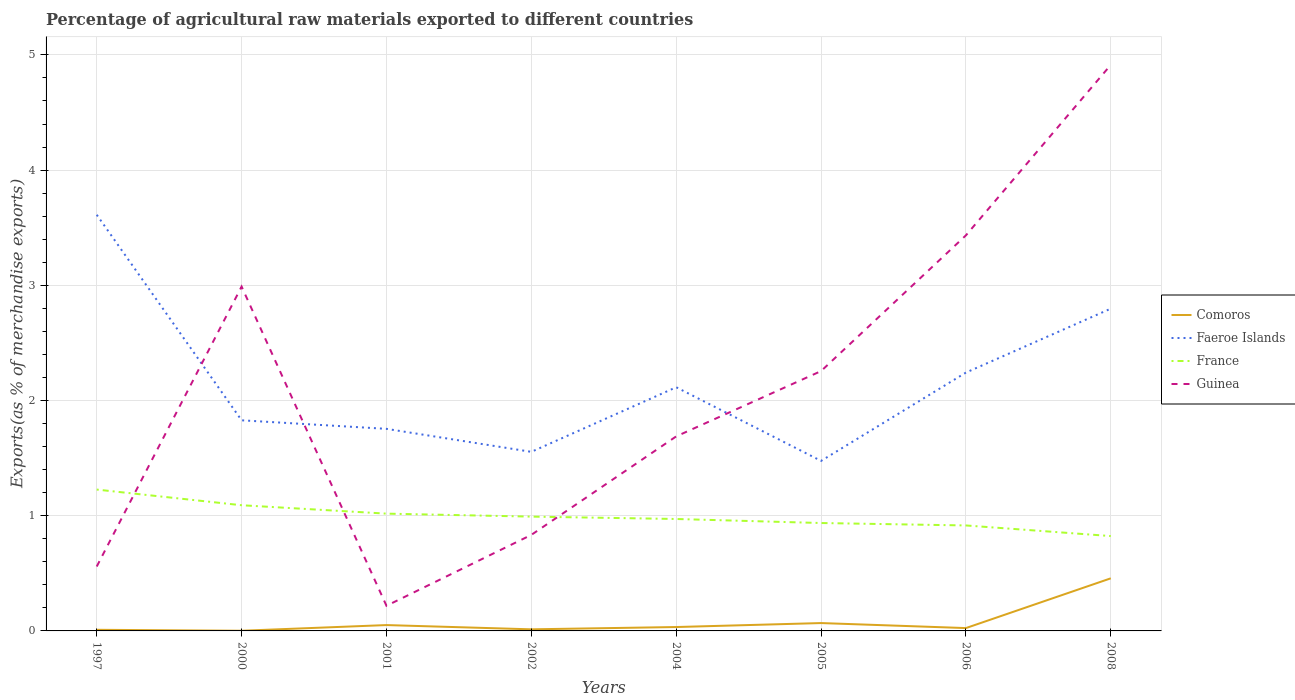Is the number of lines equal to the number of legend labels?
Provide a succinct answer. Yes. Across all years, what is the maximum percentage of exports to different countries in France?
Your response must be concise. 0.82. In which year was the percentage of exports to different countries in Guinea maximum?
Your answer should be very brief. 2001. What is the total percentage of exports to different countries in Faeroe Islands in the graph?
Offer a very short reply. -0.29. What is the difference between the highest and the second highest percentage of exports to different countries in Comoros?
Your response must be concise. 0.46. Is the percentage of exports to different countries in Comoros strictly greater than the percentage of exports to different countries in Faeroe Islands over the years?
Give a very brief answer. Yes. How many lines are there?
Offer a very short reply. 4. Where does the legend appear in the graph?
Your response must be concise. Center right. How are the legend labels stacked?
Provide a short and direct response. Vertical. What is the title of the graph?
Give a very brief answer. Percentage of agricultural raw materials exported to different countries. Does "Antigua and Barbuda" appear as one of the legend labels in the graph?
Make the answer very short. No. What is the label or title of the X-axis?
Offer a very short reply. Years. What is the label or title of the Y-axis?
Provide a short and direct response. Exports(as % of merchandise exports). What is the Exports(as % of merchandise exports) of Comoros in 1997?
Give a very brief answer. 0.01. What is the Exports(as % of merchandise exports) in Faeroe Islands in 1997?
Provide a short and direct response. 3.61. What is the Exports(as % of merchandise exports) in France in 1997?
Give a very brief answer. 1.23. What is the Exports(as % of merchandise exports) of Guinea in 1997?
Make the answer very short. 0.56. What is the Exports(as % of merchandise exports) of Comoros in 2000?
Provide a short and direct response. 0. What is the Exports(as % of merchandise exports) in Faeroe Islands in 2000?
Provide a succinct answer. 1.83. What is the Exports(as % of merchandise exports) of France in 2000?
Give a very brief answer. 1.09. What is the Exports(as % of merchandise exports) of Guinea in 2000?
Keep it short and to the point. 2.99. What is the Exports(as % of merchandise exports) in Comoros in 2001?
Provide a succinct answer. 0.05. What is the Exports(as % of merchandise exports) of Faeroe Islands in 2001?
Your answer should be compact. 1.75. What is the Exports(as % of merchandise exports) of France in 2001?
Give a very brief answer. 1.02. What is the Exports(as % of merchandise exports) of Guinea in 2001?
Your response must be concise. 0.22. What is the Exports(as % of merchandise exports) of Comoros in 2002?
Keep it short and to the point. 0.01. What is the Exports(as % of merchandise exports) of Faeroe Islands in 2002?
Provide a succinct answer. 1.55. What is the Exports(as % of merchandise exports) in France in 2002?
Your response must be concise. 0.99. What is the Exports(as % of merchandise exports) of Guinea in 2002?
Offer a very short reply. 0.83. What is the Exports(as % of merchandise exports) in Comoros in 2004?
Your answer should be very brief. 0.03. What is the Exports(as % of merchandise exports) of Faeroe Islands in 2004?
Your response must be concise. 2.12. What is the Exports(as % of merchandise exports) in France in 2004?
Your answer should be very brief. 0.97. What is the Exports(as % of merchandise exports) of Guinea in 2004?
Ensure brevity in your answer.  1.69. What is the Exports(as % of merchandise exports) in Comoros in 2005?
Offer a very short reply. 0.07. What is the Exports(as % of merchandise exports) of Faeroe Islands in 2005?
Keep it short and to the point. 1.48. What is the Exports(as % of merchandise exports) in France in 2005?
Provide a succinct answer. 0.94. What is the Exports(as % of merchandise exports) in Guinea in 2005?
Provide a short and direct response. 2.26. What is the Exports(as % of merchandise exports) of Comoros in 2006?
Provide a short and direct response. 0.02. What is the Exports(as % of merchandise exports) in Faeroe Islands in 2006?
Ensure brevity in your answer.  2.24. What is the Exports(as % of merchandise exports) in France in 2006?
Keep it short and to the point. 0.92. What is the Exports(as % of merchandise exports) of Guinea in 2006?
Provide a short and direct response. 3.43. What is the Exports(as % of merchandise exports) of Comoros in 2008?
Provide a succinct answer. 0.46. What is the Exports(as % of merchandise exports) of Faeroe Islands in 2008?
Your response must be concise. 2.8. What is the Exports(as % of merchandise exports) of France in 2008?
Keep it short and to the point. 0.82. What is the Exports(as % of merchandise exports) in Guinea in 2008?
Make the answer very short. 4.91. Across all years, what is the maximum Exports(as % of merchandise exports) of Comoros?
Offer a terse response. 0.46. Across all years, what is the maximum Exports(as % of merchandise exports) in Faeroe Islands?
Keep it short and to the point. 3.61. Across all years, what is the maximum Exports(as % of merchandise exports) of France?
Provide a succinct answer. 1.23. Across all years, what is the maximum Exports(as % of merchandise exports) in Guinea?
Make the answer very short. 4.91. Across all years, what is the minimum Exports(as % of merchandise exports) of Comoros?
Your answer should be compact. 0. Across all years, what is the minimum Exports(as % of merchandise exports) in Faeroe Islands?
Ensure brevity in your answer.  1.48. Across all years, what is the minimum Exports(as % of merchandise exports) in France?
Ensure brevity in your answer.  0.82. Across all years, what is the minimum Exports(as % of merchandise exports) in Guinea?
Ensure brevity in your answer.  0.22. What is the total Exports(as % of merchandise exports) of Comoros in the graph?
Provide a short and direct response. 0.66. What is the total Exports(as % of merchandise exports) of Faeroe Islands in the graph?
Keep it short and to the point. 17.38. What is the total Exports(as % of merchandise exports) of France in the graph?
Offer a very short reply. 7.98. What is the total Exports(as % of merchandise exports) in Guinea in the graph?
Your answer should be very brief. 16.89. What is the difference between the Exports(as % of merchandise exports) of Comoros in 1997 and that in 2000?
Give a very brief answer. 0.01. What is the difference between the Exports(as % of merchandise exports) of Faeroe Islands in 1997 and that in 2000?
Provide a short and direct response. 1.78. What is the difference between the Exports(as % of merchandise exports) of France in 1997 and that in 2000?
Offer a terse response. 0.14. What is the difference between the Exports(as % of merchandise exports) in Guinea in 1997 and that in 2000?
Make the answer very short. -2.43. What is the difference between the Exports(as % of merchandise exports) in Comoros in 1997 and that in 2001?
Ensure brevity in your answer.  -0.04. What is the difference between the Exports(as % of merchandise exports) in Faeroe Islands in 1997 and that in 2001?
Your answer should be compact. 1.86. What is the difference between the Exports(as % of merchandise exports) in France in 1997 and that in 2001?
Your answer should be compact. 0.21. What is the difference between the Exports(as % of merchandise exports) of Guinea in 1997 and that in 2001?
Your response must be concise. 0.34. What is the difference between the Exports(as % of merchandise exports) of Comoros in 1997 and that in 2002?
Offer a terse response. -0. What is the difference between the Exports(as % of merchandise exports) of Faeroe Islands in 1997 and that in 2002?
Ensure brevity in your answer.  2.06. What is the difference between the Exports(as % of merchandise exports) in France in 1997 and that in 2002?
Your answer should be very brief. 0.23. What is the difference between the Exports(as % of merchandise exports) of Guinea in 1997 and that in 2002?
Keep it short and to the point. -0.27. What is the difference between the Exports(as % of merchandise exports) in Comoros in 1997 and that in 2004?
Offer a very short reply. -0.02. What is the difference between the Exports(as % of merchandise exports) in Faeroe Islands in 1997 and that in 2004?
Ensure brevity in your answer.  1.5. What is the difference between the Exports(as % of merchandise exports) of France in 1997 and that in 2004?
Offer a very short reply. 0.26. What is the difference between the Exports(as % of merchandise exports) of Guinea in 1997 and that in 2004?
Your answer should be compact. -1.13. What is the difference between the Exports(as % of merchandise exports) in Comoros in 1997 and that in 2005?
Provide a short and direct response. -0.06. What is the difference between the Exports(as % of merchandise exports) of Faeroe Islands in 1997 and that in 2005?
Your response must be concise. 2.14. What is the difference between the Exports(as % of merchandise exports) of France in 1997 and that in 2005?
Your response must be concise. 0.29. What is the difference between the Exports(as % of merchandise exports) in Guinea in 1997 and that in 2005?
Keep it short and to the point. -1.7. What is the difference between the Exports(as % of merchandise exports) in Comoros in 1997 and that in 2006?
Your response must be concise. -0.01. What is the difference between the Exports(as % of merchandise exports) of Faeroe Islands in 1997 and that in 2006?
Keep it short and to the point. 1.37. What is the difference between the Exports(as % of merchandise exports) in France in 1997 and that in 2006?
Provide a short and direct response. 0.31. What is the difference between the Exports(as % of merchandise exports) in Guinea in 1997 and that in 2006?
Provide a short and direct response. -2.87. What is the difference between the Exports(as % of merchandise exports) of Comoros in 1997 and that in 2008?
Provide a short and direct response. -0.45. What is the difference between the Exports(as % of merchandise exports) of Faeroe Islands in 1997 and that in 2008?
Ensure brevity in your answer.  0.81. What is the difference between the Exports(as % of merchandise exports) in France in 1997 and that in 2008?
Provide a short and direct response. 0.4. What is the difference between the Exports(as % of merchandise exports) in Guinea in 1997 and that in 2008?
Ensure brevity in your answer.  -4.35. What is the difference between the Exports(as % of merchandise exports) of Comoros in 2000 and that in 2001?
Your answer should be very brief. -0.05. What is the difference between the Exports(as % of merchandise exports) of Faeroe Islands in 2000 and that in 2001?
Offer a terse response. 0.07. What is the difference between the Exports(as % of merchandise exports) in France in 2000 and that in 2001?
Keep it short and to the point. 0.07. What is the difference between the Exports(as % of merchandise exports) in Guinea in 2000 and that in 2001?
Give a very brief answer. 2.77. What is the difference between the Exports(as % of merchandise exports) of Comoros in 2000 and that in 2002?
Your answer should be very brief. -0.01. What is the difference between the Exports(as % of merchandise exports) in Faeroe Islands in 2000 and that in 2002?
Ensure brevity in your answer.  0.27. What is the difference between the Exports(as % of merchandise exports) in France in 2000 and that in 2002?
Keep it short and to the point. 0.1. What is the difference between the Exports(as % of merchandise exports) of Guinea in 2000 and that in 2002?
Make the answer very short. 2.16. What is the difference between the Exports(as % of merchandise exports) of Comoros in 2000 and that in 2004?
Give a very brief answer. -0.03. What is the difference between the Exports(as % of merchandise exports) of Faeroe Islands in 2000 and that in 2004?
Provide a short and direct response. -0.29. What is the difference between the Exports(as % of merchandise exports) of France in 2000 and that in 2004?
Provide a succinct answer. 0.12. What is the difference between the Exports(as % of merchandise exports) of Guinea in 2000 and that in 2004?
Your response must be concise. 1.3. What is the difference between the Exports(as % of merchandise exports) in Comoros in 2000 and that in 2005?
Your answer should be compact. -0.07. What is the difference between the Exports(as % of merchandise exports) in Faeroe Islands in 2000 and that in 2005?
Your response must be concise. 0.35. What is the difference between the Exports(as % of merchandise exports) of France in 2000 and that in 2005?
Provide a short and direct response. 0.15. What is the difference between the Exports(as % of merchandise exports) in Guinea in 2000 and that in 2005?
Keep it short and to the point. 0.73. What is the difference between the Exports(as % of merchandise exports) of Comoros in 2000 and that in 2006?
Provide a short and direct response. -0.02. What is the difference between the Exports(as % of merchandise exports) in Faeroe Islands in 2000 and that in 2006?
Ensure brevity in your answer.  -0.41. What is the difference between the Exports(as % of merchandise exports) of France in 2000 and that in 2006?
Keep it short and to the point. 0.18. What is the difference between the Exports(as % of merchandise exports) in Guinea in 2000 and that in 2006?
Give a very brief answer. -0.44. What is the difference between the Exports(as % of merchandise exports) in Comoros in 2000 and that in 2008?
Provide a succinct answer. -0.46. What is the difference between the Exports(as % of merchandise exports) of Faeroe Islands in 2000 and that in 2008?
Ensure brevity in your answer.  -0.97. What is the difference between the Exports(as % of merchandise exports) of France in 2000 and that in 2008?
Make the answer very short. 0.27. What is the difference between the Exports(as % of merchandise exports) in Guinea in 2000 and that in 2008?
Offer a very short reply. -1.92. What is the difference between the Exports(as % of merchandise exports) in Comoros in 2001 and that in 2002?
Provide a short and direct response. 0.04. What is the difference between the Exports(as % of merchandise exports) of Faeroe Islands in 2001 and that in 2002?
Make the answer very short. 0.2. What is the difference between the Exports(as % of merchandise exports) of France in 2001 and that in 2002?
Offer a very short reply. 0.03. What is the difference between the Exports(as % of merchandise exports) of Guinea in 2001 and that in 2002?
Provide a succinct answer. -0.62. What is the difference between the Exports(as % of merchandise exports) of Comoros in 2001 and that in 2004?
Offer a very short reply. 0.02. What is the difference between the Exports(as % of merchandise exports) in Faeroe Islands in 2001 and that in 2004?
Give a very brief answer. -0.36. What is the difference between the Exports(as % of merchandise exports) in France in 2001 and that in 2004?
Your answer should be very brief. 0.05. What is the difference between the Exports(as % of merchandise exports) of Guinea in 2001 and that in 2004?
Provide a short and direct response. -1.47. What is the difference between the Exports(as % of merchandise exports) of Comoros in 2001 and that in 2005?
Provide a succinct answer. -0.02. What is the difference between the Exports(as % of merchandise exports) in Faeroe Islands in 2001 and that in 2005?
Offer a very short reply. 0.28. What is the difference between the Exports(as % of merchandise exports) in France in 2001 and that in 2005?
Make the answer very short. 0.08. What is the difference between the Exports(as % of merchandise exports) in Guinea in 2001 and that in 2005?
Give a very brief answer. -2.04. What is the difference between the Exports(as % of merchandise exports) of Comoros in 2001 and that in 2006?
Keep it short and to the point. 0.03. What is the difference between the Exports(as % of merchandise exports) in Faeroe Islands in 2001 and that in 2006?
Make the answer very short. -0.49. What is the difference between the Exports(as % of merchandise exports) in France in 2001 and that in 2006?
Give a very brief answer. 0.1. What is the difference between the Exports(as % of merchandise exports) in Guinea in 2001 and that in 2006?
Your answer should be compact. -3.22. What is the difference between the Exports(as % of merchandise exports) of Comoros in 2001 and that in 2008?
Ensure brevity in your answer.  -0.41. What is the difference between the Exports(as % of merchandise exports) in Faeroe Islands in 2001 and that in 2008?
Provide a succinct answer. -1.04. What is the difference between the Exports(as % of merchandise exports) of France in 2001 and that in 2008?
Your answer should be very brief. 0.19. What is the difference between the Exports(as % of merchandise exports) of Guinea in 2001 and that in 2008?
Provide a short and direct response. -4.7. What is the difference between the Exports(as % of merchandise exports) in Comoros in 2002 and that in 2004?
Provide a succinct answer. -0.02. What is the difference between the Exports(as % of merchandise exports) of Faeroe Islands in 2002 and that in 2004?
Provide a short and direct response. -0.56. What is the difference between the Exports(as % of merchandise exports) in France in 2002 and that in 2004?
Ensure brevity in your answer.  0.02. What is the difference between the Exports(as % of merchandise exports) in Guinea in 2002 and that in 2004?
Your answer should be compact. -0.85. What is the difference between the Exports(as % of merchandise exports) in Comoros in 2002 and that in 2005?
Offer a terse response. -0.05. What is the difference between the Exports(as % of merchandise exports) in Faeroe Islands in 2002 and that in 2005?
Make the answer very short. 0.08. What is the difference between the Exports(as % of merchandise exports) in France in 2002 and that in 2005?
Provide a succinct answer. 0.06. What is the difference between the Exports(as % of merchandise exports) in Guinea in 2002 and that in 2005?
Give a very brief answer. -1.42. What is the difference between the Exports(as % of merchandise exports) in Comoros in 2002 and that in 2006?
Your answer should be very brief. -0.01. What is the difference between the Exports(as % of merchandise exports) of Faeroe Islands in 2002 and that in 2006?
Keep it short and to the point. -0.69. What is the difference between the Exports(as % of merchandise exports) in France in 2002 and that in 2006?
Give a very brief answer. 0.08. What is the difference between the Exports(as % of merchandise exports) in Guinea in 2002 and that in 2006?
Your response must be concise. -2.6. What is the difference between the Exports(as % of merchandise exports) of Comoros in 2002 and that in 2008?
Your answer should be compact. -0.44. What is the difference between the Exports(as % of merchandise exports) in Faeroe Islands in 2002 and that in 2008?
Offer a terse response. -1.24. What is the difference between the Exports(as % of merchandise exports) in France in 2002 and that in 2008?
Make the answer very short. 0.17. What is the difference between the Exports(as % of merchandise exports) in Guinea in 2002 and that in 2008?
Make the answer very short. -4.08. What is the difference between the Exports(as % of merchandise exports) in Comoros in 2004 and that in 2005?
Provide a succinct answer. -0.03. What is the difference between the Exports(as % of merchandise exports) of Faeroe Islands in 2004 and that in 2005?
Give a very brief answer. 0.64. What is the difference between the Exports(as % of merchandise exports) of France in 2004 and that in 2005?
Provide a succinct answer. 0.04. What is the difference between the Exports(as % of merchandise exports) of Guinea in 2004 and that in 2005?
Your response must be concise. -0.57. What is the difference between the Exports(as % of merchandise exports) of Comoros in 2004 and that in 2006?
Your answer should be compact. 0.01. What is the difference between the Exports(as % of merchandise exports) of Faeroe Islands in 2004 and that in 2006?
Offer a very short reply. -0.13. What is the difference between the Exports(as % of merchandise exports) of France in 2004 and that in 2006?
Your answer should be compact. 0.06. What is the difference between the Exports(as % of merchandise exports) of Guinea in 2004 and that in 2006?
Give a very brief answer. -1.75. What is the difference between the Exports(as % of merchandise exports) of Comoros in 2004 and that in 2008?
Keep it short and to the point. -0.42. What is the difference between the Exports(as % of merchandise exports) in Faeroe Islands in 2004 and that in 2008?
Offer a very short reply. -0.68. What is the difference between the Exports(as % of merchandise exports) of France in 2004 and that in 2008?
Offer a very short reply. 0.15. What is the difference between the Exports(as % of merchandise exports) in Guinea in 2004 and that in 2008?
Your answer should be very brief. -3.23. What is the difference between the Exports(as % of merchandise exports) of Comoros in 2005 and that in 2006?
Offer a terse response. 0.04. What is the difference between the Exports(as % of merchandise exports) in Faeroe Islands in 2005 and that in 2006?
Ensure brevity in your answer.  -0.77. What is the difference between the Exports(as % of merchandise exports) of France in 2005 and that in 2006?
Your response must be concise. 0.02. What is the difference between the Exports(as % of merchandise exports) in Guinea in 2005 and that in 2006?
Your response must be concise. -1.18. What is the difference between the Exports(as % of merchandise exports) in Comoros in 2005 and that in 2008?
Offer a very short reply. -0.39. What is the difference between the Exports(as % of merchandise exports) of Faeroe Islands in 2005 and that in 2008?
Offer a terse response. -1.32. What is the difference between the Exports(as % of merchandise exports) of France in 2005 and that in 2008?
Give a very brief answer. 0.11. What is the difference between the Exports(as % of merchandise exports) in Guinea in 2005 and that in 2008?
Your answer should be very brief. -2.66. What is the difference between the Exports(as % of merchandise exports) of Comoros in 2006 and that in 2008?
Your answer should be compact. -0.43. What is the difference between the Exports(as % of merchandise exports) in Faeroe Islands in 2006 and that in 2008?
Make the answer very short. -0.55. What is the difference between the Exports(as % of merchandise exports) in France in 2006 and that in 2008?
Give a very brief answer. 0.09. What is the difference between the Exports(as % of merchandise exports) of Guinea in 2006 and that in 2008?
Make the answer very short. -1.48. What is the difference between the Exports(as % of merchandise exports) of Comoros in 1997 and the Exports(as % of merchandise exports) of Faeroe Islands in 2000?
Offer a terse response. -1.82. What is the difference between the Exports(as % of merchandise exports) of Comoros in 1997 and the Exports(as % of merchandise exports) of France in 2000?
Your response must be concise. -1.08. What is the difference between the Exports(as % of merchandise exports) in Comoros in 1997 and the Exports(as % of merchandise exports) in Guinea in 2000?
Your answer should be very brief. -2.98. What is the difference between the Exports(as % of merchandise exports) of Faeroe Islands in 1997 and the Exports(as % of merchandise exports) of France in 2000?
Your response must be concise. 2.52. What is the difference between the Exports(as % of merchandise exports) of Faeroe Islands in 1997 and the Exports(as % of merchandise exports) of Guinea in 2000?
Offer a very short reply. 0.62. What is the difference between the Exports(as % of merchandise exports) of France in 1997 and the Exports(as % of merchandise exports) of Guinea in 2000?
Keep it short and to the point. -1.76. What is the difference between the Exports(as % of merchandise exports) in Comoros in 1997 and the Exports(as % of merchandise exports) in Faeroe Islands in 2001?
Your answer should be very brief. -1.74. What is the difference between the Exports(as % of merchandise exports) of Comoros in 1997 and the Exports(as % of merchandise exports) of France in 2001?
Provide a short and direct response. -1.01. What is the difference between the Exports(as % of merchandise exports) in Comoros in 1997 and the Exports(as % of merchandise exports) in Guinea in 2001?
Offer a terse response. -0.21. What is the difference between the Exports(as % of merchandise exports) of Faeroe Islands in 1997 and the Exports(as % of merchandise exports) of France in 2001?
Provide a succinct answer. 2.59. What is the difference between the Exports(as % of merchandise exports) in Faeroe Islands in 1997 and the Exports(as % of merchandise exports) in Guinea in 2001?
Make the answer very short. 3.39. What is the difference between the Exports(as % of merchandise exports) of France in 1997 and the Exports(as % of merchandise exports) of Guinea in 2001?
Make the answer very short. 1.01. What is the difference between the Exports(as % of merchandise exports) in Comoros in 1997 and the Exports(as % of merchandise exports) in Faeroe Islands in 2002?
Offer a terse response. -1.54. What is the difference between the Exports(as % of merchandise exports) of Comoros in 1997 and the Exports(as % of merchandise exports) of France in 2002?
Ensure brevity in your answer.  -0.98. What is the difference between the Exports(as % of merchandise exports) in Comoros in 1997 and the Exports(as % of merchandise exports) in Guinea in 2002?
Offer a very short reply. -0.82. What is the difference between the Exports(as % of merchandise exports) in Faeroe Islands in 1997 and the Exports(as % of merchandise exports) in France in 2002?
Give a very brief answer. 2.62. What is the difference between the Exports(as % of merchandise exports) of Faeroe Islands in 1997 and the Exports(as % of merchandise exports) of Guinea in 2002?
Make the answer very short. 2.78. What is the difference between the Exports(as % of merchandise exports) of France in 1997 and the Exports(as % of merchandise exports) of Guinea in 2002?
Your answer should be compact. 0.39. What is the difference between the Exports(as % of merchandise exports) in Comoros in 1997 and the Exports(as % of merchandise exports) in Faeroe Islands in 2004?
Your answer should be very brief. -2.11. What is the difference between the Exports(as % of merchandise exports) in Comoros in 1997 and the Exports(as % of merchandise exports) in France in 2004?
Make the answer very short. -0.96. What is the difference between the Exports(as % of merchandise exports) of Comoros in 1997 and the Exports(as % of merchandise exports) of Guinea in 2004?
Your response must be concise. -1.68. What is the difference between the Exports(as % of merchandise exports) of Faeroe Islands in 1997 and the Exports(as % of merchandise exports) of France in 2004?
Ensure brevity in your answer.  2.64. What is the difference between the Exports(as % of merchandise exports) in Faeroe Islands in 1997 and the Exports(as % of merchandise exports) in Guinea in 2004?
Provide a succinct answer. 1.92. What is the difference between the Exports(as % of merchandise exports) in France in 1997 and the Exports(as % of merchandise exports) in Guinea in 2004?
Your answer should be very brief. -0.46. What is the difference between the Exports(as % of merchandise exports) of Comoros in 1997 and the Exports(as % of merchandise exports) of Faeroe Islands in 2005?
Offer a terse response. -1.47. What is the difference between the Exports(as % of merchandise exports) of Comoros in 1997 and the Exports(as % of merchandise exports) of France in 2005?
Your answer should be very brief. -0.93. What is the difference between the Exports(as % of merchandise exports) in Comoros in 1997 and the Exports(as % of merchandise exports) in Guinea in 2005?
Offer a terse response. -2.25. What is the difference between the Exports(as % of merchandise exports) of Faeroe Islands in 1997 and the Exports(as % of merchandise exports) of France in 2005?
Keep it short and to the point. 2.68. What is the difference between the Exports(as % of merchandise exports) of Faeroe Islands in 1997 and the Exports(as % of merchandise exports) of Guinea in 2005?
Your response must be concise. 1.36. What is the difference between the Exports(as % of merchandise exports) of France in 1997 and the Exports(as % of merchandise exports) of Guinea in 2005?
Offer a terse response. -1.03. What is the difference between the Exports(as % of merchandise exports) of Comoros in 1997 and the Exports(as % of merchandise exports) of Faeroe Islands in 2006?
Your answer should be very brief. -2.23. What is the difference between the Exports(as % of merchandise exports) of Comoros in 1997 and the Exports(as % of merchandise exports) of France in 2006?
Provide a succinct answer. -0.91. What is the difference between the Exports(as % of merchandise exports) of Comoros in 1997 and the Exports(as % of merchandise exports) of Guinea in 2006?
Ensure brevity in your answer.  -3.42. What is the difference between the Exports(as % of merchandise exports) of Faeroe Islands in 1997 and the Exports(as % of merchandise exports) of France in 2006?
Your response must be concise. 2.7. What is the difference between the Exports(as % of merchandise exports) in Faeroe Islands in 1997 and the Exports(as % of merchandise exports) in Guinea in 2006?
Keep it short and to the point. 0.18. What is the difference between the Exports(as % of merchandise exports) of France in 1997 and the Exports(as % of merchandise exports) of Guinea in 2006?
Provide a short and direct response. -2.21. What is the difference between the Exports(as % of merchandise exports) of Comoros in 1997 and the Exports(as % of merchandise exports) of Faeroe Islands in 2008?
Your answer should be compact. -2.79. What is the difference between the Exports(as % of merchandise exports) in Comoros in 1997 and the Exports(as % of merchandise exports) in France in 2008?
Offer a terse response. -0.81. What is the difference between the Exports(as % of merchandise exports) of Comoros in 1997 and the Exports(as % of merchandise exports) of Guinea in 2008?
Your answer should be very brief. -4.9. What is the difference between the Exports(as % of merchandise exports) in Faeroe Islands in 1997 and the Exports(as % of merchandise exports) in France in 2008?
Offer a terse response. 2.79. What is the difference between the Exports(as % of merchandise exports) of Faeroe Islands in 1997 and the Exports(as % of merchandise exports) of Guinea in 2008?
Offer a very short reply. -1.3. What is the difference between the Exports(as % of merchandise exports) in France in 1997 and the Exports(as % of merchandise exports) in Guinea in 2008?
Your response must be concise. -3.69. What is the difference between the Exports(as % of merchandise exports) in Comoros in 2000 and the Exports(as % of merchandise exports) in Faeroe Islands in 2001?
Provide a short and direct response. -1.75. What is the difference between the Exports(as % of merchandise exports) in Comoros in 2000 and the Exports(as % of merchandise exports) in France in 2001?
Your answer should be very brief. -1.02. What is the difference between the Exports(as % of merchandise exports) in Comoros in 2000 and the Exports(as % of merchandise exports) in Guinea in 2001?
Your answer should be very brief. -0.22. What is the difference between the Exports(as % of merchandise exports) of Faeroe Islands in 2000 and the Exports(as % of merchandise exports) of France in 2001?
Offer a terse response. 0.81. What is the difference between the Exports(as % of merchandise exports) of Faeroe Islands in 2000 and the Exports(as % of merchandise exports) of Guinea in 2001?
Offer a very short reply. 1.61. What is the difference between the Exports(as % of merchandise exports) of France in 2000 and the Exports(as % of merchandise exports) of Guinea in 2001?
Provide a succinct answer. 0.87. What is the difference between the Exports(as % of merchandise exports) in Comoros in 2000 and the Exports(as % of merchandise exports) in Faeroe Islands in 2002?
Offer a terse response. -1.55. What is the difference between the Exports(as % of merchandise exports) in Comoros in 2000 and the Exports(as % of merchandise exports) in France in 2002?
Ensure brevity in your answer.  -0.99. What is the difference between the Exports(as % of merchandise exports) of Comoros in 2000 and the Exports(as % of merchandise exports) of Guinea in 2002?
Give a very brief answer. -0.83. What is the difference between the Exports(as % of merchandise exports) in Faeroe Islands in 2000 and the Exports(as % of merchandise exports) in France in 2002?
Provide a succinct answer. 0.84. What is the difference between the Exports(as % of merchandise exports) in France in 2000 and the Exports(as % of merchandise exports) in Guinea in 2002?
Ensure brevity in your answer.  0.26. What is the difference between the Exports(as % of merchandise exports) in Comoros in 2000 and the Exports(as % of merchandise exports) in Faeroe Islands in 2004?
Keep it short and to the point. -2.11. What is the difference between the Exports(as % of merchandise exports) in Comoros in 2000 and the Exports(as % of merchandise exports) in France in 2004?
Offer a very short reply. -0.97. What is the difference between the Exports(as % of merchandise exports) in Comoros in 2000 and the Exports(as % of merchandise exports) in Guinea in 2004?
Offer a very short reply. -1.69. What is the difference between the Exports(as % of merchandise exports) in Faeroe Islands in 2000 and the Exports(as % of merchandise exports) in France in 2004?
Offer a terse response. 0.86. What is the difference between the Exports(as % of merchandise exports) of Faeroe Islands in 2000 and the Exports(as % of merchandise exports) of Guinea in 2004?
Provide a succinct answer. 0.14. What is the difference between the Exports(as % of merchandise exports) in France in 2000 and the Exports(as % of merchandise exports) in Guinea in 2004?
Ensure brevity in your answer.  -0.6. What is the difference between the Exports(as % of merchandise exports) in Comoros in 2000 and the Exports(as % of merchandise exports) in Faeroe Islands in 2005?
Provide a short and direct response. -1.47. What is the difference between the Exports(as % of merchandise exports) of Comoros in 2000 and the Exports(as % of merchandise exports) of France in 2005?
Ensure brevity in your answer.  -0.94. What is the difference between the Exports(as % of merchandise exports) of Comoros in 2000 and the Exports(as % of merchandise exports) of Guinea in 2005?
Ensure brevity in your answer.  -2.25. What is the difference between the Exports(as % of merchandise exports) of Faeroe Islands in 2000 and the Exports(as % of merchandise exports) of France in 2005?
Give a very brief answer. 0.89. What is the difference between the Exports(as % of merchandise exports) of Faeroe Islands in 2000 and the Exports(as % of merchandise exports) of Guinea in 2005?
Your answer should be very brief. -0.43. What is the difference between the Exports(as % of merchandise exports) in France in 2000 and the Exports(as % of merchandise exports) in Guinea in 2005?
Your answer should be compact. -1.16. What is the difference between the Exports(as % of merchandise exports) of Comoros in 2000 and the Exports(as % of merchandise exports) of Faeroe Islands in 2006?
Your response must be concise. -2.24. What is the difference between the Exports(as % of merchandise exports) of Comoros in 2000 and the Exports(as % of merchandise exports) of France in 2006?
Offer a terse response. -0.91. What is the difference between the Exports(as % of merchandise exports) of Comoros in 2000 and the Exports(as % of merchandise exports) of Guinea in 2006?
Your answer should be compact. -3.43. What is the difference between the Exports(as % of merchandise exports) in Faeroe Islands in 2000 and the Exports(as % of merchandise exports) in France in 2006?
Provide a short and direct response. 0.91. What is the difference between the Exports(as % of merchandise exports) of Faeroe Islands in 2000 and the Exports(as % of merchandise exports) of Guinea in 2006?
Offer a terse response. -1.61. What is the difference between the Exports(as % of merchandise exports) of France in 2000 and the Exports(as % of merchandise exports) of Guinea in 2006?
Ensure brevity in your answer.  -2.34. What is the difference between the Exports(as % of merchandise exports) in Comoros in 2000 and the Exports(as % of merchandise exports) in Faeroe Islands in 2008?
Provide a succinct answer. -2.8. What is the difference between the Exports(as % of merchandise exports) of Comoros in 2000 and the Exports(as % of merchandise exports) of France in 2008?
Keep it short and to the point. -0.82. What is the difference between the Exports(as % of merchandise exports) of Comoros in 2000 and the Exports(as % of merchandise exports) of Guinea in 2008?
Offer a terse response. -4.91. What is the difference between the Exports(as % of merchandise exports) of Faeroe Islands in 2000 and the Exports(as % of merchandise exports) of France in 2008?
Offer a very short reply. 1. What is the difference between the Exports(as % of merchandise exports) in Faeroe Islands in 2000 and the Exports(as % of merchandise exports) in Guinea in 2008?
Your answer should be very brief. -3.09. What is the difference between the Exports(as % of merchandise exports) of France in 2000 and the Exports(as % of merchandise exports) of Guinea in 2008?
Your answer should be very brief. -3.82. What is the difference between the Exports(as % of merchandise exports) of Comoros in 2001 and the Exports(as % of merchandise exports) of Faeroe Islands in 2002?
Offer a terse response. -1.5. What is the difference between the Exports(as % of merchandise exports) of Comoros in 2001 and the Exports(as % of merchandise exports) of France in 2002?
Provide a succinct answer. -0.94. What is the difference between the Exports(as % of merchandise exports) of Comoros in 2001 and the Exports(as % of merchandise exports) of Guinea in 2002?
Make the answer very short. -0.78. What is the difference between the Exports(as % of merchandise exports) of Faeroe Islands in 2001 and the Exports(as % of merchandise exports) of France in 2002?
Your answer should be compact. 0.76. What is the difference between the Exports(as % of merchandise exports) of Faeroe Islands in 2001 and the Exports(as % of merchandise exports) of Guinea in 2002?
Offer a very short reply. 0.92. What is the difference between the Exports(as % of merchandise exports) in France in 2001 and the Exports(as % of merchandise exports) in Guinea in 2002?
Keep it short and to the point. 0.18. What is the difference between the Exports(as % of merchandise exports) of Comoros in 2001 and the Exports(as % of merchandise exports) of Faeroe Islands in 2004?
Offer a very short reply. -2.06. What is the difference between the Exports(as % of merchandise exports) of Comoros in 2001 and the Exports(as % of merchandise exports) of France in 2004?
Your answer should be very brief. -0.92. What is the difference between the Exports(as % of merchandise exports) in Comoros in 2001 and the Exports(as % of merchandise exports) in Guinea in 2004?
Provide a short and direct response. -1.64. What is the difference between the Exports(as % of merchandise exports) in Faeroe Islands in 2001 and the Exports(as % of merchandise exports) in France in 2004?
Give a very brief answer. 0.78. What is the difference between the Exports(as % of merchandise exports) in Faeroe Islands in 2001 and the Exports(as % of merchandise exports) in Guinea in 2004?
Offer a very short reply. 0.07. What is the difference between the Exports(as % of merchandise exports) of France in 2001 and the Exports(as % of merchandise exports) of Guinea in 2004?
Provide a short and direct response. -0.67. What is the difference between the Exports(as % of merchandise exports) of Comoros in 2001 and the Exports(as % of merchandise exports) of Faeroe Islands in 2005?
Your answer should be compact. -1.43. What is the difference between the Exports(as % of merchandise exports) of Comoros in 2001 and the Exports(as % of merchandise exports) of France in 2005?
Your response must be concise. -0.89. What is the difference between the Exports(as % of merchandise exports) of Comoros in 2001 and the Exports(as % of merchandise exports) of Guinea in 2005?
Provide a short and direct response. -2.2. What is the difference between the Exports(as % of merchandise exports) in Faeroe Islands in 2001 and the Exports(as % of merchandise exports) in France in 2005?
Offer a terse response. 0.82. What is the difference between the Exports(as % of merchandise exports) of Faeroe Islands in 2001 and the Exports(as % of merchandise exports) of Guinea in 2005?
Ensure brevity in your answer.  -0.5. What is the difference between the Exports(as % of merchandise exports) in France in 2001 and the Exports(as % of merchandise exports) in Guinea in 2005?
Make the answer very short. -1.24. What is the difference between the Exports(as % of merchandise exports) in Comoros in 2001 and the Exports(as % of merchandise exports) in Faeroe Islands in 2006?
Your answer should be very brief. -2.19. What is the difference between the Exports(as % of merchandise exports) in Comoros in 2001 and the Exports(as % of merchandise exports) in France in 2006?
Keep it short and to the point. -0.86. What is the difference between the Exports(as % of merchandise exports) of Comoros in 2001 and the Exports(as % of merchandise exports) of Guinea in 2006?
Give a very brief answer. -3.38. What is the difference between the Exports(as % of merchandise exports) of Faeroe Islands in 2001 and the Exports(as % of merchandise exports) of France in 2006?
Offer a very short reply. 0.84. What is the difference between the Exports(as % of merchandise exports) in Faeroe Islands in 2001 and the Exports(as % of merchandise exports) in Guinea in 2006?
Make the answer very short. -1.68. What is the difference between the Exports(as % of merchandise exports) in France in 2001 and the Exports(as % of merchandise exports) in Guinea in 2006?
Provide a succinct answer. -2.42. What is the difference between the Exports(as % of merchandise exports) of Comoros in 2001 and the Exports(as % of merchandise exports) of Faeroe Islands in 2008?
Keep it short and to the point. -2.75. What is the difference between the Exports(as % of merchandise exports) in Comoros in 2001 and the Exports(as % of merchandise exports) in France in 2008?
Give a very brief answer. -0.77. What is the difference between the Exports(as % of merchandise exports) in Comoros in 2001 and the Exports(as % of merchandise exports) in Guinea in 2008?
Your response must be concise. -4.86. What is the difference between the Exports(as % of merchandise exports) of Faeroe Islands in 2001 and the Exports(as % of merchandise exports) of France in 2008?
Provide a succinct answer. 0.93. What is the difference between the Exports(as % of merchandise exports) of Faeroe Islands in 2001 and the Exports(as % of merchandise exports) of Guinea in 2008?
Make the answer very short. -3.16. What is the difference between the Exports(as % of merchandise exports) of France in 2001 and the Exports(as % of merchandise exports) of Guinea in 2008?
Offer a terse response. -3.9. What is the difference between the Exports(as % of merchandise exports) of Comoros in 2002 and the Exports(as % of merchandise exports) of Faeroe Islands in 2004?
Your response must be concise. -2.1. What is the difference between the Exports(as % of merchandise exports) of Comoros in 2002 and the Exports(as % of merchandise exports) of France in 2004?
Offer a very short reply. -0.96. What is the difference between the Exports(as % of merchandise exports) in Comoros in 2002 and the Exports(as % of merchandise exports) in Guinea in 2004?
Make the answer very short. -1.67. What is the difference between the Exports(as % of merchandise exports) of Faeroe Islands in 2002 and the Exports(as % of merchandise exports) of France in 2004?
Keep it short and to the point. 0.58. What is the difference between the Exports(as % of merchandise exports) in Faeroe Islands in 2002 and the Exports(as % of merchandise exports) in Guinea in 2004?
Provide a succinct answer. -0.13. What is the difference between the Exports(as % of merchandise exports) in France in 2002 and the Exports(as % of merchandise exports) in Guinea in 2004?
Keep it short and to the point. -0.7. What is the difference between the Exports(as % of merchandise exports) of Comoros in 2002 and the Exports(as % of merchandise exports) of Faeroe Islands in 2005?
Give a very brief answer. -1.46. What is the difference between the Exports(as % of merchandise exports) of Comoros in 2002 and the Exports(as % of merchandise exports) of France in 2005?
Your response must be concise. -0.92. What is the difference between the Exports(as % of merchandise exports) of Comoros in 2002 and the Exports(as % of merchandise exports) of Guinea in 2005?
Your response must be concise. -2.24. What is the difference between the Exports(as % of merchandise exports) of Faeroe Islands in 2002 and the Exports(as % of merchandise exports) of France in 2005?
Offer a terse response. 0.62. What is the difference between the Exports(as % of merchandise exports) of Faeroe Islands in 2002 and the Exports(as % of merchandise exports) of Guinea in 2005?
Ensure brevity in your answer.  -0.7. What is the difference between the Exports(as % of merchandise exports) in France in 2002 and the Exports(as % of merchandise exports) in Guinea in 2005?
Your answer should be very brief. -1.26. What is the difference between the Exports(as % of merchandise exports) in Comoros in 2002 and the Exports(as % of merchandise exports) in Faeroe Islands in 2006?
Offer a terse response. -2.23. What is the difference between the Exports(as % of merchandise exports) of Comoros in 2002 and the Exports(as % of merchandise exports) of France in 2006?
Offer a very short reply. -0.9. What is the difference between the Exports(as % of merchandise exports) in Comoros in 2002 and the Exports(as % of merchandise exports) in Guinea in 2006?
Give a very brief answer. -3.42. What is the difference between the Exports(as % of merchandise exports) of Faeroe Islands in 2002 and the Exports(as % of merchandise exports) of France in 2006?
Provide a short and direct response. 0.64. What is the difference between the Exports(as % of merchandise exports) in Faeroe Islands in 2002 and the Exports(as % of merchandise exports) in Guinea in 2006?
Your answer should be compact. -1.88. What is the difference between the Exports(as % of merchandise exports) of France in 2002 and the Exports(as % of merchandise exports) of Guinea in 2006?
Your answer should be compact. -2.44. What is the difference between the Exports(as % of merchandise exports) in Comoros in 2002 and the Exports(as % of merchandise exports) in Faeroe Islands in 2008?
Provide a short and direct response. -2.78. What is the difference between the Exports(as % of merchandise exports) of Comoros in 2002 and the Exports(as % of merchandise exports) of France in 2008?
Give a very brief answer. -0.81. What is the difference between the Exports(as % of merchandise exports) in Comoros in 2002 and the Exports(as % of merchandise exports) in Guinea in 2008?
Provide a short and direct response. -4.9. What is the difference between the Exports(as % of merchandise exports) of Faeroe Islands in 2002 and the Exports(as % of merchandise exports) of France in 2008?
Your answer should be compact. 0.73. What is the difference between the Exports(as % of merchandise exports) of Faeroe Islands in 2002 and the Exports(as % of merchandise exports) of Guinea in 2008?
Your response must be concise. -3.36. What is the difference between the Exports(as % of merchandise exports) of France in 2002 and the Exports(as % of merchandise exports) of Guinea in 2008?
Make the answer very short. -3.92. What is the difference between the Exports(as % of merchandise exports) of Comoros in 2004 and the Exports(as % of merchandise exports) of Faeroe Islands in 2005?
Your response must be concise. -1.44. What is the difference between the Exports(as % of merchandise exports) in Comoros in 2004 and the Exports(as % of merchandise exports) in France in 2005?
Your response must be concise. -0.9. What is the difference between the Exports(as % of merchandise exports) of Comoros in 2004 and the Exports(as % of merchandise exports) of Guinea in 2005?
Make the answer very short. -2.22. What is the difference between the Exports(as % of merchandise exports) of Faeroe Islands in 2004 and the Exports(as % of merchandise exports) of France in 2005?
Your answer should be very brief. 1.18. What is the difference between the Exports(as % of merchandise exports) in Faeroe Islands in 2004 and the Exports(as % of merchandise exports) in Guinea in 2005?
Your answer should be very brief. -0.14. What is the difference between the Exports(as % of merchandise exports) of France in 2004 and the Exports(as % of merchandise exports) of Guinea in 2005?
Provide a succinct answer. -1.28. What is the difference between the Exports(as % of merchandise exports) of Comoros in 2004 and the Exports(as % of merchandise exports) of Faeroe Islands in 2006?
Make the answer very short. -2.21. What is the difference between the Exports(as % of merchandise exports) in Comoros in 2004 and the Exports(as % of merchandise exports) in France in 2006?
Ensure brevity in your answer.  -0.88. What is the difference between the Exports(as % of merchandise exports) in Comoros in 2004 and the Exports(as % of merchandise exports) in Guinea in 2006?
Keep it short and to the point. -3.4. What is the difference between the Exports(as % of merchandise exports) in Faeroe Islands in 2004 and the Exports(as % of merchandise exports) in France in 2006?
Provide a succinct answer. 1.2. What is the difference between the Exports(as % of merchandise exports) of Faeroe Islands in 2004 and the Exports(as % of merchandise exports) of Guinea in 2006?
Make the answer very short. -1.32. What is the difference between the Exports(as % of merchandise exports) of France in 2004 and the Exports(as % of merchandise exports) of Guinea in 2006?
Give a very brief answer. -2.46. What is the difference between the Exports(as % of merchandise exports) of Comoros in 2004 and the Exports(as % of merchandise exports) of Faeroe Islands in 2008?
Offer a very short reply. -2.76. What is the difference between the Exports(as % of merchandise exports) in Comoros in 2004 and the Exports(as % of merchandise exports) in France in 2008?
Ensure brevity in your answer.  -0.79. What is the difference between the Exports(as % of merchandise exports) of Comoros in 2004 and the Exports(as % of merchandise exports) of Guinea in 2008?
Ensure brevity in your answer.  -4.88. What is the difference between the Exports(as % of merchandise exports) in Faeroe Islands in 2004 and the Exports(as % of merchandise exports) in France in 2008?
Ensure brevity in your answer.  1.29. What is the difference between the Exports(as % of merchandise exports) in Faeroe Islands in 2004 and the Exports(as % of merchandise exports) in Guinea in 2008?
Provide a short and direct response. -2.8. What is the difference between the Exports(as % of merchandise exports) in France in 2004 and the Exports(as % of merchandise exports) in Guinea in 2008?
Provide a short and direct response. -3.94. What is the difference between the Exports(as % of merchandise exports) of Comoros in 2005 and the Exports(as % of merchandise exports) of Faeroe Islands in 2006?
Keep it short and to the point. -2.17. What is the difference between the Exports(as % of merchandise exports) of Comoros in 2005 and the Exports(as % of merchandise exports) of France in 2006?
Your response must be concise. -0.85. What is the difference between the Exports(as % of merchandise exports) of Comoros in 2005 and the Exports(as % of merchandise exports) of Guinea in 2006?
Provide a short and direct response. -3.37. What is the difference between the Exports(as % of merchandise exports) in Faeroe Islands in 2005 and the Exports(as % of merchandise exports) in France in 2006?
Make the answer very short. 0.56. What is the difference between the Exports(as % of merchandise exports) in Faeroe Islands in 2005 and the Exports(as % of merchandise exports) in Guinea in 2006?
Provide a succinct answer. -1.96. What is the difference between the Exports(as % of merchandise exports) in France in 2005 and the Exports(as % of merchandise exports) in Guinea in 2006?
Make the answer very short. -2.5. What is the difference between the Exports(as % of merchandise exports) in Comoros in 2005 and the Exports(as % of merchandise exports) in Faeroe Islands in 2008?
Keep it short and to the point. -2.73. What is the difference between the Exports(as % of merchandise exports) in Comoros in 2005 and the Exports(as % of merchandise exports) in France in 2008?
Offer a very short reply. -0.76. What is the difference between the Exports(as % of merchandise exports) of Comoros in 2005 and the Exports(as % of merchandise exports) of Guinea in 2008?
Provide a short and direct response. -4.85. What is the difference between the Exports(as % of merchandise exports) in Faeroe Islands in 2005 and the Exports(as % of merchandise exports) in France in 2008?
Your answer should be compact. 0.65. What is the difference between the Exports(as % of merchandise exports) of Faeroe Islands in 2005 and the Exports(as % of merchandise exports) of Guinea in 2008?
Provide a short and direct response. -3.44. What is the difference between the Exports(as % of merchandise exports) of France in 2005 and the Exports(as % of merchandise exports) of Guinea in 2008?
Offer a terse response. -3.98. What is the difference between the Exports(as % of merchandise exports) in Comoros in 2006 and the Exports(as % of merchandise exports) in Faeroe Islands in 2008?
Ensure brevity in your answer.  -2.77. What is the difference between the Exports(as % of merchandise exports) in Comoros in 2006 and the Exports(as % of merchandise exports) in France in 2008?
Make the answer very short. -0.8. What is the difference between the Exports(as % of merchandise exports) in Comoros in 2006 and the Exports(as % of merchandise exports) in Guinea in 2008?
Offer a terse response. -4.89. What is the difference between the Exports(as % of merchandise exports) in Faeroe Islands in 2006 and the Exports(as % of merchandise exports) in France in 2008?
Make the answer very short. 1.42. What is the difference between the Exports(as % of merchandise exports) of Faeroe Islands in 2006 and the Exports(as % of merchandise exports) of Guinea in 2008?
Your answer should be very brief. -2.67. What is the difference between the Exports(as % of merchandise exports) of France in 2006 and the Exports(as % of merchandise exports) of Guinea in 2008?
Keep it short and to the point. -4. What is the average Exports(as % of merchandise exports) of Comoros per year?
Provide a short and direct response. 0.08. What is the average Exports(as % of merchandise exports) of Faeroe Islands per year?
Make the answer very short. 2.17. What is the average Exports(as % of merchandise exports) of Guinea per year?
Give a very brief answer. 2.11. In the year 1997, what is the difference between the Exports(as % of merchandise exports) in Comoros and Exports(as % of merchandise exports) in Faeroe Islands?
Keep it short and to the point. -3.6. In the year 1997, what is the difference between the Exports(as % of merchandise exports) of Comoros and Exports(as % of merchandise exports) of France?
Offer a very short reply. -1.22. In the year 1997, what is the difference between the Exports(as % of merchandise exports) in Comoros and Exports(as % of merchandise exports) in Guinea?
Your answer should be compact. -0.55. In the year 1997, what is the difference between the Exports(as % of merchandise exports) of Faeroe Islands and Exports(as % of merchandise exports) of France?
Provide a short and direct response. 2.39. In the year 1997, what is the difference between the Exports(as % of merchandise exports) of Faeroe Islands and Exports(as % of merchandise exports) of Guinea?
Keep it short and to the point. 3.05. In the year 1997, what is the difference between the Exports(as % of merchandise exports) in France and Exports(as % of merchandise exports) in Guinea?
Ensure brevity in your answer.  0.67. In the year 2000, what is the difference between the Exports(as % of merchandise exports) of Comoros and Exports(as % of merchandise exports) of Faeroe Islands?
Offer a terse response. -1.83. In the year 2000, what is the difference between the Exports(as % of merchandise exports) of Comoros and Exports(as % of merchandise exports) of France?
Provide a short and direct response. -1.09. In the year 2000, what is the difference between the Exports(as % of merchandise exports) of Comoros and Exports(as % of merchandise exports) of Guinea?
Your answer should be very brief. -2.99. In the year 2000, what is the difference between the Exports(as % of merchandise exports) in Faeroe Islands and Exports(as % of merchandise exports) in France?
Ensure brevity in your answer.  0.74. In the year 2000, what is the difference between the Exports(as % of merchandise exports) of Faeroe Islands and Exports(as % of merchandise exports) of Guinea?
Ensure brevity in your answer.  -1.16. In the year 2000, what is the difference between the Exports(as % of merchandise exports) in France and Exports(as % of merchandise exports) in Guinea?
Give a very brief answer. -1.9. In the year 2001, what is the difference between the Exports(as % of merchandise exports) of Comoros and Exports(as % of merchandise exports) of Faeroe Islands?
Your answer should be very brief. -1.7. In the year 2001, what is the difference between the Exports(as % of merchandise exports) of Comoros and Exports(as % of merchandise exports) of France?
Give a very brief answer. -0.97. In the year 2001, what is the difference between the Exports(as % of merchandise exports) of Comoros and Exports(as % of merchandise exports) of Guinea?
Provide a succinct answer. -0.17. In the year 2001, what is the difference between the Exports(as % of merchandise exports) of Faeroe Islands and Exports(as % of merchandise exports) of France?
Ensure brevity in your answer.  0.74. In the year 2001, what is the difference between the Exports(as % of merchandise exports) in Faeroe Islands and Exports(as % of merchandise exports) in Guinea?
Provide a short and direct response. 1.54. In the year 2001, what is the difference between the Exports(as % of merchandise exports) of France and Exports(as % of merchandise exports) of Guinea?
Provide a short and direct response. 0.8. In the year 2002, what is the difference between the Exports(as % of merchandise exports) in Comoros and Exports(as % of merchandise exports) in Faeroe Islands?
Provide a succinct answer. -1.54. In the year 2002, what is the difference between the Exports(as % of merchandise exports) of Comoros and Exports(as % of merchandise exports) of France?
Give a very brief answer. -0.98. In the year 2002, what is the difference between the Exports(as % of merchandise exports) in Comoros and Exports(as % of merchandise exports) in Guinea?
Ensure brevity in your answer.  -0.82. In the year 2002, what is the difference between the Exports(as % of merchandise exports) of Faeroe Islands and Exports(as % of merchandise exports) of France?
Your response must be concise. 0.56. In the year 2002, what is the difference between the Exports(as % of merchandise exports) of Faeroe Islands and Exports(as % of merchandise exports) of Guinea?
Ensure brevity in your answer.  0.72. In the year 2002, what is the difference between the Exports(as % of merchandise exports) of France and Exports(as % of merchandise exports) of Guinea?
Give a very brief answer. 0.16. In the year 2004, what is the difference between the Exports(as % of merchandise exports) in Comoros and Exports(as % of merchandise exports) in Faeroe Islands?
Make the answer very short. -2.08. In the year 2004, what is the difference between the Exports(as % of merchandise exports) of Comoros and Exports(as % of merchandise exports) of France?
Your answer should be compact. -0.94. In the year 2004, what is the difference between the Exports(as % of merchandise exports) of Comoros and Exports(as % of merchandise exports) of Guinea?
Offer a very short reply. -1.65. In the year 2004, what is the difference between the Exports(as % of merchandise exports) in Faeroe Islands and Exports(as % of merchandise exports) in France?
Your answer should be very brief. 1.14. In the year 2004, what is the difference between the Exports(as % of merchandise exports) of Faeroe Islands and Exports(as % of merchandise exports) of Guinea?
Your answer should be very brief. 0.43. In the year 2004, what is the difference between the Exports(as % of merchandise exports) of France and Exports(as % of merchandise exports) of Guinea?
Ensure brevity in your answer.  -0.72. In the year 2005, what is the difference between the Exports(as % of merchandise exports) of Comoros and Exports(as % of merchandise exports) of Faeroe Islands?
Your answer should be very brief. -1.41. In the year 2005, what is the difference between the Exports(as % of merchandise exports) in Comoros and Exports(as % of merchandise exports) in France?
Provide a short and direct response. -0.87. In the year 2005, what is the difference between the Exports(as % of merchandise exports) of Comoros and Exports(as % of merchandise exports) of Guinea?
Provide a succinct answer. -2.19. In the year 2005, what is the difference between the Exports(as % of merchandise exports) of Faeroe Islands and Exports(as % of merchandise exports) of France?
Your answer should be compact. 0.54. In the year 2005, what is the difference between the Exports(as % of merchandise exports) of Faeroe Islands and Exports(as % of merchandise exports) of Guinea?
Your response must be concise. -0.78. In the year 2005, what is the difference between the Exports(as % of merchandise exports) in France and Exports(as % of merchandise exports) in Guinea?
Your response must be concise. -1.32. In the year 2006, what is the difference between the Exports(as % of merchandise exports) in Comoros and Exports(as % of merchandise exports) in Faeroe Islands?
Your response must be concise. -2.22. In the year 2006, what is the difference between the Exports(as % of merchandise exports) in Comoros and Exports(as % of merchandise exports) in France?
Your answer should be compact. -0.89. In the year 2006, what is the difference between the Exports(as % of merchandise exports) of Comoros and Exports(as % of merchandise exports) of Guinea?
Your response must be concise. -3.41. In the year 2006, what is the difference between the Exports(as % of merchandise exports) of Faeroe Islands and Exports(as % of merchandise exports) of France?
Make the answer very short. 1.33. In the year 2006, what is the difference between the Exports(as % of merchandise exports) of Faeroe Islands and Exports(as % of merchandise exports) of Guinea?
Give a very brief answer. -1.19. In the year 2006, what is the difference between the Exports(as % of merchandise exports) in France and Exports(as % of merchandise exports) in Guinea?
Your response must be concise. -2.52. In the year 2008, what is the difference between the Exports(as % of merchandise exports) of Comoros and Exports(as % of merchandise exports) of Faeroe Islands?
Provide a short and direct response. -2.34. In the year 2008, what is the difference between the Exports(as % of merchandise exports) of Comoros and Exports(as % of merchandise exports) of France?
Offer a very short reply. -0.37. In the year 2008, what is the difference between the Exports(as % of merchandise exports) of Comoros and Exports(as % of merchandise exports) of Guinea?
Offer a very short reply. -4.46. In the year 2008, what is the difference between the Exports(as % of merchandise exports) of Faeroe Islands and Exports(as % of merchandise exports) of France?
Your answer should be compact. 1.97. In the year 2008, what is the difference between the Exports(as % of merchandise exports) in Faeroe Islands and Exports(as % of merchandise exports) in Guinea?
Give a very brief answer. -2.12. In the year 2008, what is the difference between the Exports(as % of merchandise exports) in France and Exports(as % of merchandise exports) in Guinea?
Your answer should be very brief. -4.09. What is the ratio of the Exports(as % of merchandise exports) in Comoros in 1997 to that in 2000?
Your answer should be very brief. 6.24. What is the ratio of the Exports(as % of merchandise exports) of Faeroe Islands in 1997 to that in 2000?
Provide a succinct answer. 1.98. What is the ratio of the Exports(as % of merchandise exports) of France in 1997 to that in 2000?
Provide a succinct answer. 1.12. What is the ratio of the Exports(as % of merchandise exports) of Guinea in 1997 to that in 2000?
Your answer should be compact. 0.19. What is the ratio of the Exports(as % of merchandise exports) in Comoros in 1997 to that in 2001?
Keep it short and to the point. 0.19. What is the ratio of the Exports(as % of merchandise exports) in Faeroe Islands in 1997 to that in 2001?
Your answer should be compact. 2.06. What is the ratio of the Exports(as % of merchandise exports) in France in 1997 to that in 2001?
Your answer should be very brief. 1.21. What is the ratio of the Exports(as % of merchandise exports) in Guinea in 1997 to that in 2001?
Offer a very short reply. 2.56. What is the ratio of the Exports(as % of merchandise exports) in Comoros in 1997 to that in 2002?
Provide a succinct answer. 0.7. What is the ratio of the Exports(as % of merchandise exports) of Faeroe Islands in 1997 to that in 2002?
Provide a succinct answer. 2.32. What is the ratio of the Exports(as % of merchandise exports) of France in 1997 to that in 2002?
Your answer should be compact. 1.24. What is the ratio of the Exports(as % of merchandise exports) of Guinea in 1997 to that in 2002?
Your answer should be compact. 0.67. What is the ratio of the Exports(as % of merchandise exports) of Comoros in 1997 to that in 2004?
Offer a terse response. 0.29. What is the ratio of the Exports(as % of merchandise exports) in Faeroe Islands in 1997 to that in 2004?
Offer a very short reply. 1.71. What is the ratio of the Exports(as % of merchandise exports) of France in 1997 to that in 2004?
Offer a terse response. 1.26. What is the ratio of the Exports(as % of merchandise exports) in Guinea in 1997 to that in 2004?
Give a very brief answer. 0.33. What is the ratio of the Exports(as % of merchandise exports) of Comoros in 1997 to that in 2005?
Provide a succinct answer. 0.14. What is the ratio of the Exports(as % of merchandise exports) in Faeroe Islands in 1997 to that in 2005?
Your answer should be compact. 2.45. What is the ratio of the Exports(as % of merchandise exports) in France in 1997 to that in 2005?
Ensure brevity in your answer.  1.31. What is the ratio of the Exports(as % of merchandise exports) of Guinea in 1997 to that in 2005?
Provide a succinct answer. 0.25. What is the ratio of the Exports(as % of merchandise exports) of Comoros in 1997 to that in 2006?
Make the answer very short. 0.39. What is the ratio of the Exports(as % of merchandise exports) of Faeroe Islands in 1997 to that in 2006?
Ensure brevity in your answer.  1.61. What is the ratio of the Exports(as % of merchandise exports) of France in 1997 to that in 2006?
Your answer should be compact. 1.34. What is the ratio of the Exports(as % of merchandise exports) of Guinea in 1997 to that in 2006?
Make the answer very short. 0.16. What is the ratio of the Exports(as % of merchandise exports) of Comoros in 1997 to that in 2008?
Offer a very short reply. 0.02. What is the ratio of the Exports(as % of merchandise exports) in Faeroe Islands in 1997 to that in 2008?
Your answer should be compact. 1.29. What is the ratio of the Exports(as % of merchandise exports) in France in 1997 to that in 2008?
Your response must be concise. 1.49. What is the ratio of the Exports(as % of merchandise exports) in Guinea in 1997 to that in 2008?
Give a very brief answer. 0.11. What is the ratio of the Exports(as % of merchandise exports) in Comoros in 2000 to that in 2001?
Ensure brevity in your answer.  0.03. What is the ratio of the Exports(as % of merchandise exports) of Faeroe Islands in 2000 to that in 2001?
Your answer should be compact. 1.04. What is the ratio of the Exports(as % of merchandise exports) of France in 2000 to that in 2001?
Ensure brevity in your answer.  1.07. What is the ratio of the Exports(as % of merchandise exports) of Guinea in 2000 to that in 2001?
Make the answer very short. 13.7. What is the ratio of the Exports(as % of merchandise exports) of Comoros in 2000 to that in 2002?
Keep it short and to the point. 0.11. What is the ratio of the Exports(as % of merchandise exports) in Faeroe Islands in 2000 to that in 2002?
Provide a succinct answer. 1.18. What is the ratio of the Exports(as % of merchandise exports) of France in 2000 to that in 2002?
Ensure brevity in your answer.  1.1. What is the ratio of the Exports(as % of merchandise exports) in Guinea in 2000 to that in 2002?
Provide a short and direct response. 3.59. What is the ratio of the Exports(as % of merchandise exports) in Comoros in 2000 to that in 2004?
Give a very brief answer. 0.05. What is the ratio of the Exports(as % of merchandise exports) in Faeroe Islands in 2000 to that in 2004?
Ensure brevity in your answer.  0.86. What is the ratio of the Exports(as % of merchandise exports) of France in 2000 to that in 2004?
Provide a short and direct response. 1.12. What is the ratio of the Exports(as % of merchandise exports) in Guinea in 2000 to that in 2004?
Your answer should be compact. 1.77. What is the ratio of the Exports(as % of merchandise exports) of Comoros in 2000 to that in 2005?
Give a very brief answer. 0.02. What is the ratio of the Exports(as % of merchandise exports) in Faeroe Islands in 2000 to that in 2005?
Your answer should be very brief. 1.24. What is the ratio of the Exports(as % of merchandise exports) in France in 2000 to that in 2005?
Provide a short and direct response. 1.16. What is the ratio of the Exports(as % of merchandise exports) in Guinea in 2000 to that in 2005?
Provide a succinct answer. 1.33. What is the ratio of the Exports(as % of merchandise exports) of Comoros in 2000 to that in 2006?
Your answer should be very brief. 0.06. What is the ratio of the Exports(as % of merchandise exports) in Faeroe Islands in 2000 to that in 2006?
Give a very brief answer. 0.82. What is the ratio of the Exports(as % of merchandise exports) in France in 2000 to that in 2006?
Ensure brevity in your answer.  1.19. What is the ratio of the Exports(as % of merchandise exports) in Guinea in 2000 to that in 2006?
Make the answer very short. 0.87. What is the ratio of the Exports(as % of merchandise exports) of Comoros in 2000 to that in 2008?
Give a very brief answer. 0. What is the ratio of the Exports(as % of merchandise exports) in Faeroe Islands in 2000 to that in 2008?
Provide a succinct answer. 0.65. What is the ratio of the Exports(as % of merchandise exports) of France in 2000 to that in 2008?
Your response must be concise. 1.33. What is the ratio of the Exports(as % of merchandise exports) in Guinea in 2000 to that in 2008?
Provide a succinct answer. 0.61. What is the ratio of the Exports(as % of merchandise exports) in Comoros in 2001 to that in 2002?
Ensure brevity in your answer.  3.66. What is the ratio of the Exports(as % of merchandise exports) of Faeroe Islands in 2001 to that in 2002?
Make the answer very short. 1.13. What is the ratio of the Exports(as % of merchandise exports) in Guinea in 2001 to that in 2002?
Ensure brevity in your answer.  0.26. What is the ratio of the Exports(as % of merchandise exports) in Comoros in 2001 to that in 2004?
Keep it short and to the point. 1.51. What is the ratio of the Exports(as % of merchandise exports) of Faeroe Islands in 2001 to that in 2004?
Keep it short and to the point. 0.83. What is the ratio of the Exports(as % of merchandise exports) in France in 2001 to that in 2004?
Your answer should be compact. 1.05. What is the ratio of the Exports(as % of merchandise exports) in Guinea in 2001 to that in 2004?
Your answer should be very brief. 0.13. What is the ratio of the Exports(as % of merchandise exports) of Comoros in 2001 to that in 2005?
Your answer should be very brief. 0.74. What is the ratio of the Exports(as % of merchandise exports) in Faeroe Islands in 2001 to that in 2005?
Offer a very short reply. 1.19. What is the ratio of the Exports(as % of merchandise exports) in France in 2001 to that in 2005?
Make the answer very short. 1.09. What is the ratio of the Exports(as % of merchandise exports) of Guinea in 2001 to that in 2005?
Offer a very short reply. 0.1. What is the ratio of the Exports(as % of merchandise exports) of Comoros in 2001 to that in 2006?
Offer a very short reply. 2.06. What is the ratio of the Exports(as % of merchandise exports) of Faeroe Islands in 2001 to that in 2006?
Offer a terse response. 0.78. What is the ratio of the Exports(as % of merchandise exports) in France in 2001 to that in 2006?
Offer a terse response. 1.11. What is the ratio of the Exports(as % of merchandise exports) of Guinea in 2001 to that in 2006?
Your response must be concise. 0.06. What is the ratio of the Exports(as % of merchandise exports) of Comoros in 2001 to that in 2008?
Keep it short and to the point. 0.11. What is the ratio of the Exports(as % of merchandise exports) of Faeroe Islands in 2001 to that in 2008?
Your answer should be compact. 0.63. What is the ratio of the Exports(as % of merchandise exports) of France in 2001 to that in 2008?
Provide a succinct answer. 1.24. What is the ratio of the Exports(as % of merchandise exports) in Guinea in 2001 to that in 2008?
Offer a terse response. 0.04. What is the ratio of the Exports(as % of merchandise exports) in Comoros in 2002 to that in 2004?
Provide a succinct answer. 0.41. What is the ratio of the Exports(as % of merchandise exports) in Faeroe Islands in 2002 to that in 2004?
Provide a short and direct response. 0.73. What is the ratio of the Exports(as % of merchandise exports) in France in 2002 to that in 2004?
Your answer should be very brief. 1.02. What is the ratio of the Exports(as % of merchandise exports) of Guinea in 2002 to that in 2004?
Keep it short and to the point. 0.49. What is the ratio of the Exports(as % of merchandise exports) in Comoros in 2002 to that in 2005?
Provide a short and direct response. 0.2. What is the ratio of the Exports(as % of merchandise exports) of Faeroe Islands in 2002 to that in 2005?
Make the answer very short. 1.05. What is the ratio of the Exports(as % of merchandise exports) in France in 2002 to that in 2005?
Offer a terse response. 1.06. What is the ratio of the Exports(as % of merchandise exports) of Guinea in 2002 to that in 2005?
Provide a succinct answer. 0.37. What is the ratio of the Exports(as % of merchandise exports) in Comoros in 2002 to that in 2006?
Offer a very short reply. 0.56. What is the ratio of the Exports(as % of merchandise exports) in Faeroe Islands in 2002 to that in 2006?
Offer a very short reply. 0.69. What is the ratio of the Exports(as % of merchandise exports) in France in 2002 to that in 2006?
Ensure brevity in your answer.  1.08. What is the ratio of the Exports(as % of merchandise exports) in Guinea in 2002 to that in 2006?
Provide a short and direct response. 0.24. What is the ratio of the Exports(as % of merchandise exports) in Comoros in 2002 to that in 2008?
Make the answer very short. 0.03. What is the ratio of the Exports(as % of merchandise exports) of Faeroe Islands in 2002 to that in 2008?
Offer a terse response. 0.56. What is the ratio of the Exports(as % of merchandise exports) of France in 2002 to that in 2008?
Your answer should be very brief. 1.21. What is the ratio of the Exports(as % of merchandise exports) in Guinea in 2002 to that in 2008?
Your answer should be very brief. 0.17. What is the ratio of the Exports(as % of merchandise exports) in Comoros in 2004 to that in 2005?
Make the answer very short. 0.49. What is the ratio of the Exports(as % of merchandise exports) in Faeroe Islands in 2004 to that in 2005?
Provide a short and direct response. 1.43. What is the ratio of the Exports(as % of merchandise exports) of France in 2004 to that in 2005?
Ensure brevity in your answer.  1.04. What is the ratio of the Exports(as % of merchandise exports) in Guinea in 2004 to that in 2005?
Offer a terse response. 0.75. What is the ratio of the Exports(as % of merchandise exports) in Comoros in 2004 to that in 2006?
Your response must be concise. 1.37. What is the ratio of the Exports(as % of merchandise exports) of Faeroe Islands in 2004 to that in 2006?
Provide a short and direct response. 0.94. What is the ratio of the Exports(as % of merchandise exports) of France in 2004 to that in 2006?
Provide a succinct answer. 1.06. What is the ratio of the Exports(as % of merchandise exports) of Guinea in 2004 to that in 2006?
Your answer should be compact. 0.49. What is the ratio of the Exports(as % of merchandise exports) of Comoros in 2004 to that in 2008?
Offer a terse response. 0.07. What is the ratio of the Exports(as % of merchandise exports) of Faeroe Islands in 2004 to that in 2008?
Keep it short and to the point. 0.76. What is the ratio of the Exports(as % of merchandise exports) of France in 2004 to that in 2008?
Your response must be concise. 1.18. What is the ratio of the Exports(as % of merchandise exports) of Guinea in 2004 to that in 2008?
Keep it short and to the point. 0.34. What is the ratio of the Exports(as % of merchandise exports) in Comoros in 2005 to that in 2006?
Keep it short and to the point. 2.76. What is the ratio of the Exports(as % of merchandise exports) of Faeroe Islands in 2005 to that in 2006?
Ensure brevity in your answer.  0.66. What is the ratio of the Exports(as % of merchandise exports) in France in 2005 to that in 2006?
Your answer should be compact. 1.02. What is the ratio of the Exports(as % of merchandise exports) in Guinea in 2005 to that in 2006?
Offer a terse response. 0.66. What is the ratio of the Exports(as % of merchandise exports) in Comoros in 2005 to that in 2008?
Offer a very short reply. 0.15. What is the ratio of the Exports(as % of merchandise exports) of Faeroe Islands in 2005 to that in 2008?
Offer a terse response. 0.53. What is the ratio of the Exports(as % of merchandise exports) in France in 2005 to that in 2008?
Offer a very short reply. 1.14. What is the ratio of the Exports(as % of merchandise exports) in Guinea in 2005 to that in 2008?
Your answer should be compact. 0.46. What is the ratio of the Exports(as % of merchandise exports) of Comoros in 2006 to that in 2008?
Offer a very short reply. 0.05. What is the ratio of the Exports(as % of merchandise exports) of Faeroe Islands in 2006 to that in 2008?
Offer a very short reply. 0.8. What is the ratio of the Exports(as % of merchandise exports) of France in 2006 to that in 2008?
Offer a very short reply. 1.11. What is the ratio of the Exports(as % of merchandise exports) in Guinea in 2006 to that in 2008?
Give a very brief answer. 0.7. What is the difference between the highest and the second highest Exports(as % of merchandise exports) of Comoros?
Offer a very short reply. 0.39. What is the difference between the highest and the second highest Exports(as % of merchandise exports) of Faeroe Islands?
Make the answer very short. 0.81. What is the difference between the highest and the second highest Exports(as % of merchandise exports) of France?
Ensure brevity in your answer.  0.14. What is the difference between the highest and the second highest Exports(as % of merchandise exports) in Guinea?
Offer a terse response. 1.48. What is the difference between the highest and the lowest Exports(as % of merchandise exports) in Comoros?
Your response must be concise. 0.46. What is the difference between the highest and the lowest Exports(as % of merchandise exports) of Faeroe Islands?
Offer a terse response. 2.14. What is the difference between the highest and the lowest Exports(as % of merchandise exports) in France?
Ensure brevity in your answer.  0.4. What is the difference between the highest and the lowest Exports(as % of merchandise exports) in Guinea?
Your answer should be very brief. 4.7. 